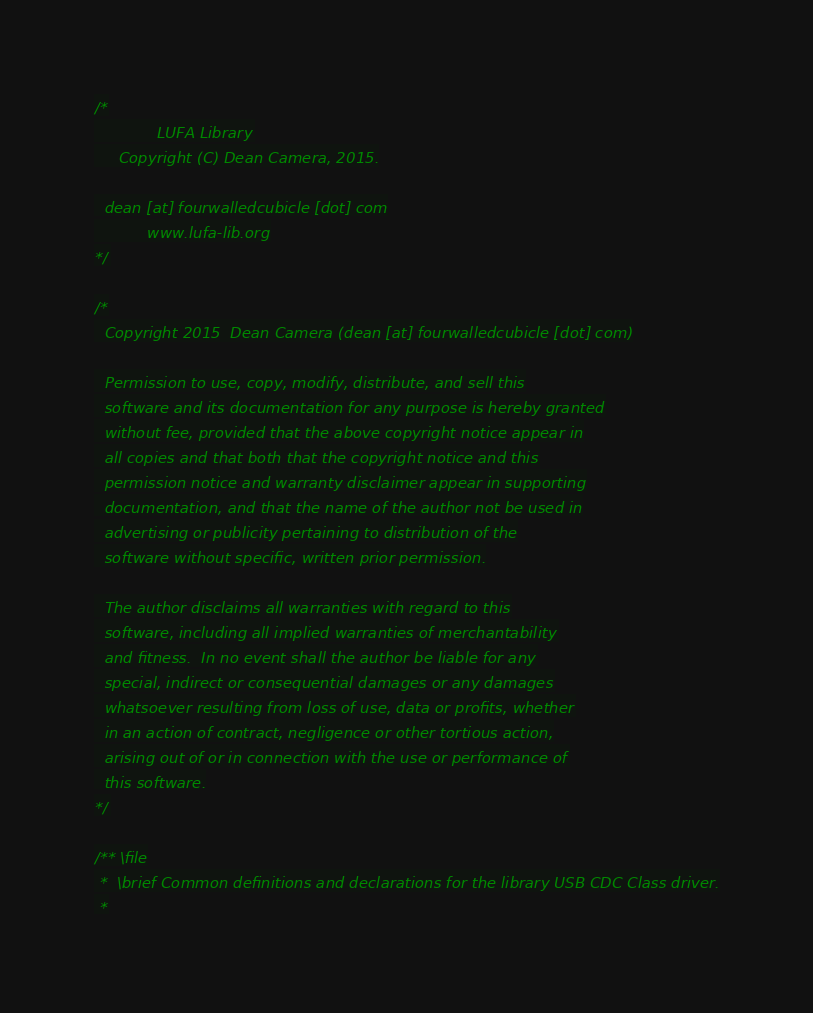<code> <loc_0><loc_0><loc_500><loc_500><_C_>/*
             LUFA Library
     Copyright (C) Dean Camera, 2015.

  dean [at] fourwalledcubicle [dot] com
           www.lufa-lib.org
*/

/*
  Copyright 2015  Dean Camera (dean [at] fourwalledcubicle [dot] com)

  Permission to use, copy, modify, distribute, and sell this
  software and its documentation for any purpose is hereby granted
  without fee, provided that the above copyright notice appear in
  all copies and that both that the copyright notice and this
  permission notice and warranty disclaimer appear in supporting
  documentation, and that the name of the author not be used in
  advertising or publicity pertaining to distribution of the
  software without specific, written prior permission.

  The author disclaims all warranties with regard to this
  software, including all implied warranties of merchantability
  and fitness.  In no event shall the author be liable for any
  special, indirect or consequential damages or any damages
  whatsoever resulting from loss of use, data or profits, whether
  in an action of contract, negligence or other tortious action,
  arising out of or in connection with the use or performance of
  this software.
*/

/** \file
 *  \brief Common definitions and declarations for the library USB CDC Class driver.
 *</code> 